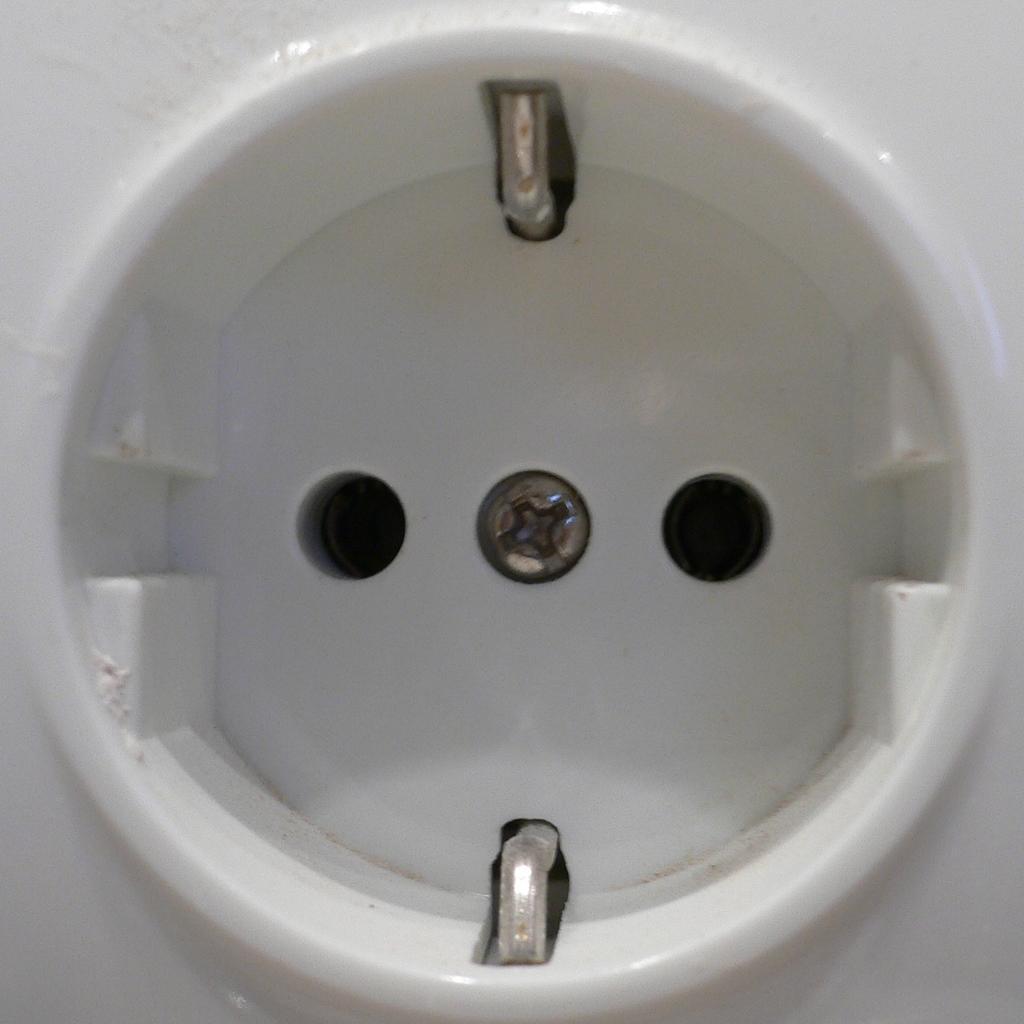Could you give a brief overview of what you see in this image? In this image there is a socket. 